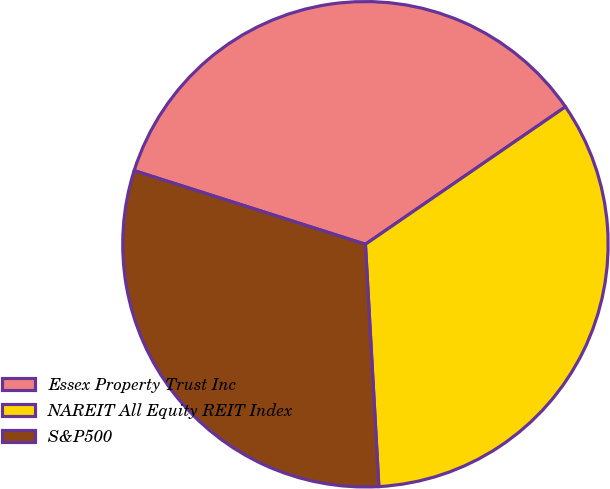Convert chart. <chart><loc_0><loc_0><loc_500><loc_500><pie_chart><fcel>Essex Property Trust Inc<fcel>NAREIT All Equity REIT Index<fcel>S&P500<nl><fcel>35.51%<fcel>33.7%<fcel>30.79%<nl></chart> 